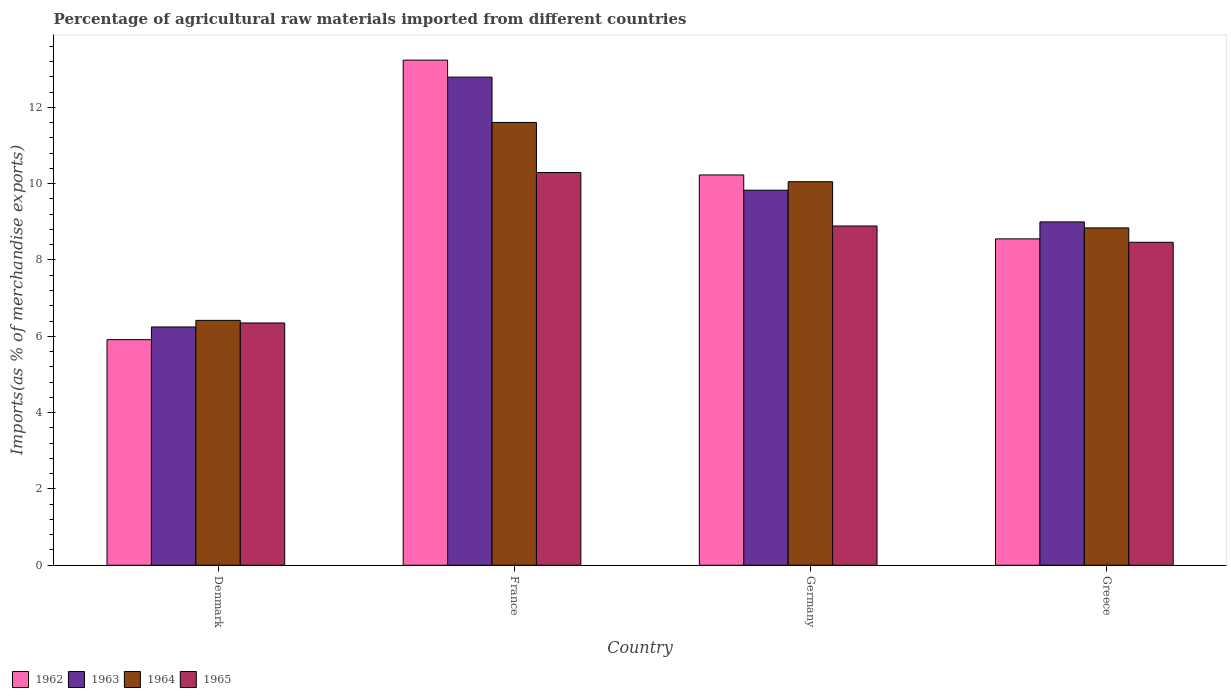How many different coloured bars are there?
Provide a succinct answer. 4. Are the number of bars on each tick of the X-axis equal?
Give a very brief answer. Yes. How many bars are there on the 3rd tick from the left?
Offer a very short reply. 4. How many bars are there on the 3rd tick from the right?
Make the answer very short. 4. What is the label of the 3rd group of bars from the left?
Your answer should be very brief. Germany. In how many cases, is the number of bars for a given country not equal to the number of legend labels?
Keep it short and to the point. 0. What is the percentage of imports to different countries in 1965 in France?
Offer a terse response. 10.29. Across all countries, what is the maximum percentage of imports to different countries in 1965?
Provide a short and direct response. 10.29. Across all countries, what is the minimum percentage of imports to different countries in 1965?
Give a very brief answer. 6.35. In which country was the percentage of imports to different countries in 1965 maximum?
Make the answer very short. France. What is the total percentage of imports to different countries in 1962 in the graph?
Offer a very short reply. 37.93. What is the difference between the percentage of imports to different countries in 1963 in France and that in Greece?
Keep it short and to the point. 3.79. What is the difference between the percentage of imports to different countries in 1964 in Denmark and the percentage of imports to different countries in 1963 in Germany?
Your response must be concise. -3.41. What is the average percentage of imports to different countries in 1964 per country?
Give a very brief answer. 9.23. What is the difference between the percentage of imports to different countries of/in 1963 and percentage of imports to different countries of/in 1964 in France?
Ensure brevity in your answer.  1.19. In how many countries, is the percentage of imports to different countries in 1965 greater than 5.2 %?
Make the answer very short. 4. What is the ratio of the percentage of imports to different countries in 1965 in Denmark to that in France?
Your answer should be very brief. 0.62. What is the difference between the highest and the second highest percentage of imports to different countries in 1962?
Offer a very short reply. -1.67. What is the difference between the highest and the lowest percentage of imports to different countries in 1964?
Ensure brevity in your answer.  5.19. In how many countries, is the percentage of imports to different countries in 1963 greater than the average percentage of imports to different countries in 1963 taken over all countries?
Ensure brevity in your answer.  2. Is the sum of the percentage of imports to different countries in 1965 in Germany and Greece greater than the maximum percentage of imports to different countries in 1962 across all countries?
Provide a succinct answer. Yes. What does the 2nd bar from the right in Germany represents?
Keep it short and to the point. 1964. What is the difference between two consecutive major ticks on the Y-axis?
Give a very brief answer. 2. Does the graph contain any zero values?
Your response must be concise. No. Where does the legend appear in the graph?
Keep it short and to the point. Bottom left. How many legend labels are there?
Your answer should be very brief. 4. What is the title of the graph?
Offer a very short reply. Percentage of agricultural raw materials imported from different countries. What is the label or title of the Y-axis?
Give a very brief answer. Imports(as % of merchandise exports). What is the Imports(as % of merchandise exports) of 1962 in Denmark?
Give a very brief answer. 5.91. What is the Imports(as % of merchandise exports) of 1963 in Denmark?
Offer a terse response. 6.24. What is the Imports(as % of merchandise exports) of 1964 in Denmark?
Keep it short and to the point. 6.42. What is the Imports(as % of merchandise exports) in 1965 in Denmark?
Provide a short and direct response. 6.35. What is the Imports(as % of merchandise exports) in 1962 in France?
Your response must be concise. 13.24. What is the Imports(as % of merchandise exports) of 1963 in France?
Provide a succinct answer. 12.79. What is the Imports(as % of merchandise exports) of 1964 in France?
Give a very brief answer. 11.6. What is the Imports(as % of merchandise exports) in 1965 in France?
Your answer should be very brief. 10.29. What is the Imports(as % of merchandise exports) in 1962 in Germany?
Your answer should be very brief. 10.23. What is the Imports(as % of merchandise exports) of 1963 in Germany?
Provide a succinct answer. 9.83. What is the Imports(as % of merchandise exports) in 1964 in Germany?
Offer a terse response. 10.05. What is the Imports(as % of merchandise exports) in 1965 in Germany?
Offer a terse response. 8.89. What is the Imports(as % of merchandise exports) in 1962 in Greece?
Provide a succinct answer. 8.55. What is the Imports(as % of merchandise exports) in 1963 in Greece?
Provide a succinct answer. 9. What is the Imports(as % of merchandise exports) in 1964 in Greece?
Ensure brevity in your answer.  8.84. What is the Imports(as % of merchandise exports) of 1965 in Greece?
Offer a terse response. 8.46. Across all countries, what is the maximum Imports(as % of merchandise exports) of 1962?
Your answer should be very brief. 13.24. Across all countries, what is the maximum Imports(as % of merchandise exports) of 1963?
Offer a terse response. 12.79. Across all countries, what is the maximum Imports(as % of merchandise exports) in 1964?
Ensure brevity in your answer.  11.6. Across all countries, what is the maximum Imports(as % of merchandise exports) in 1965?
Offer a very short reply. 10.29. Across all countries, what is the minimum Imports(as % of merchandise exports) in 1962?
Offer a terse response. 5.91. Across all countries, what is the minimum Imports(as % of merchandise exports) in 1963?
Provide a succinct answer. 6.24. Across all countries, what is the minimum Imports(as % of merchandise exports) in 1964?
Your answer should be compact. 6.42. Across all countries, what is the minimum Imports(as % of merchandise exports) in 1965?
Make the answer very short. 6.35. What is the total Imports(as % of merchandise exports) in 1962 in the graph?
Your answer should be compact. 37.93. What is the total Imports(as % of merchandise exports) in 1963 in the graph?
Your answer should be very brief. 37.86. What is the total Imports(as % of merchandise exports) in 1964 in the graph?
Provide a succinct answer. 36.91. What is the total Imports(as % of merchandise exports) of 1965 in the graph?
Provide a short and direct response. 33.99. What is the difference between the Imports(as % of merchandise exports) in 1962 in Denmark and that in France?
Make the answer very short. -7.32. What is the difference between the Imports(as % of merchandise exports) of 1963 in Denmark and that in France?
Ensure brevity in your answer.  -6.55. What is the difference between the Imports(as % of merchandise exports) of 1964 in Denmark and that in France?
Give a very brief answer. -5.19. What is the difference between the Imports(as % of merchandise exports) in 1965 in Denmark and that in France?
Your answer should be compact. -3.94. What is the difference between the Imports(as % of merchandise exports) of 1962 in Denmark and that in Germany?
Give a very brief answer. -4.32. What is the difference between the Imports(as % of merchandise exports) in 1963 in Denmark and that in Germany?
Keep it short and to the point. -3.58. What is the difference between the Imports(as % of merchandise exports) of 1964 in Denmark and that in Germany?
Offer a very short reply. -3.63. What is the difference between the Imports(as % of merchandise exports) in 1965 in Denmark and that in Germany?
Offer a terse response. -2.54. What is the difference between the Imports(as % of merchandise exports) in 1962 in Denmark and that in Greece?
Offer a very short reply. -2.64. What is the difference between the Imports(as % of merchandise exports) of 1963 in Denmark and that in Greece?
Keep it short and to the point. -2.75. What is the difference between the Imports(as % of merchandise exports) of 1964 in Denmark and that in Greece?
Keep it short and to the point. -2.42. What is the difference between the Imports(as % of merchandise exports) of 1965 in Denmark and that in Greece?
Make the answer very short. -2.11. What is the difference between the Imports(as % of merchandise exports) of 1962 in France and that in Germany?
Make the answer very short. 3.01. What is the difference between the Imports(as % of merchandise exports) of 1963 in France and that in Germany?
Ensure brevity in your answer.  2.96. What is the difference between the Imports(as % of merchandise exports) in 1964 in France and that in Germany?
Your response must be concise. 1.55. What is the difference between the Imports(as % of merchandise exports) of 1965 in France and that in Germany?
Offer a very short reply. 1.4. What is the difference between the Imports(as % of merchandise exports) of 1962 in France and that in Greece?
Offer a very short reply. 4.68. What is the difference between the Imports(as % of merchandise exports) of 1963 in France and that in Greece?
Ensure brevity in your answer.  3.79. What is the difference between the Imports(as % of merchandise exports) of 1964 in France and that in Greece?
Your answer should be compact. 2.76. What is the difference between the Imports(as % of merchandise exports) in 1965 in France and that in Greece?
Offer a terse response. 1.83. What is the difference between the Imports(as % of merchandise exports) of 1962 in Germany and that in Greece?
Offer a very short reply. 1.67. What is the difference between the Imports(as % of merchandise exports) in 1963 in Germany and that in Greece?
Offer a very short reply. 0.83. What is the difference between the Imports(as % of merchandise exports) in 1964 in Germany and that in Greece?
Provide a short and direct response. 1.21. What is the difference between the Imports(as % of merchandise exports) in 1965 in Germany and that in Greece?
Provide a succinct answer. 0.43. What is the difference between the Imports(as % of merchandise exports) of 1962 in Denmark and the Imports(as % of merchandise exports) of 1963 in France?
Offer a terse response. -6.88. What is the difference between the Imports(as % of merchandise exports) of 1962 in Denmark and the Imports(as % of merchandise exports) of 1964 in France?
Your answer should be compact. -5.69. What is the difference between the Imports(as % of merchandise exports) in 1962 in Denmark and the Imports(as % of merchandise exports) in 1965 in France?
Your answer should be very brief. -4.38. What is the difference between the Imports(as % of merchandise exports) in 1963 in Denmark and the Imports(as % of merchandise exports) in 1964 in France?
Keep it short and to the point. -5.36. What is the difference between the Imports(as % of merchandise exports) in 1963 in Denmark and the Imports(as % of merchandise exports) in 1965 in France?
Keep it short and to the point. -4.05. What is the difference between the Imports(as % of merchandise exports) in 1964 in Denmark and the Imports(as % of merchandise exports) in 1965 in France?
Give a very brief answer. -3.87. What is the difference between the Imports(as % of merchandise exports) in 1962 in Denmark and the Imports(as % of merchandise exports) in 1963 in Germany?
Keep it short and to the point. -3.92. What is the difference between the Imports(as % of merchandise exports) of 1962 in Denmark and the Imports(as % of merchandise exports) of 1964 in Germany?
Offer a terse response. -4.14. What is the difference between the Imports(as % of merchandise exports) of 1962 in Denmark and the Imports(as % of merchandise exports) of 1965 in Germany?
Keep it short and to the point. -2.98. What is the difference between the Imports(as % of merchandise exports) of 1963 in Denmark and the Imports(as % of merchandise exports) of 1964 in Germany?
Make the answer very short. -3.81. What is the difference between the Imports(as % of merchandise exports) in 1963 in Denmark and the Imports(as % of merchandise exports) in 1965 in Germany?
Give a very brief answer. -2.65. What is the difference between the Imports(as % of merchandise exports) in 1964 in Denmark and the Imports(as % of merchandise exports) in 1965 in Germany?
Offer a very short reply. -2.47. What is the difference between the Imports(as % of merchandise exports) in 1962 in Denmark and the Imports(as % of merchandise exports) in 1963 in Greece?
Provide a short and direct response. -3.08. What is the difference between the Imports(as % of merchandise exports) of 1962 in Denmark and the Imports(as % of merchandise exports) of 1964 in Greece?
Your answer should be compact. -2.93. What is the difference between the Imports(as % of merchandise exports) in 1962 in Denmark and the Imports(as % of merchandise exports) in 1965 in Greece?
Make the answer very short. -2.55. What is the difference between the Imports(as % of merchandise exports) of 1963 in Denmark and the Imports(as % of merchandise exports) of 1964 in Greece?
Offer a very short reply. -2.6. What is the difference between the Imports(as % of merchandise exports) in 1963 in Denmark and the Imports(as % of merchandise exports) in 1965 in Greece?
Provide a succinct answer. -2.22. What is the difference between the Imports(as % of merchandise exports) in 1964 in Denmark and the Imports(as % of merchandise exports) in 1965 in Greece?
Ensure brevity in your answer.  -2.05. What is the difference between the Imports(as % of merchandise exports) of 1962 in France and the Imports(as % of merchandise exports) of 1963 in Germany?
Give a very brief answer. 3.41. What is the difference between the Imports(as % of merchandise exports) of 1962 in France and the Imports(as % of merchandise exports) of 1964 in Germany?
Your answer should be compact. 3.19. What is the difference between the Imports(as % of merchandise exports) in 1962 in France and the Imports(as % of merchandise exports) in 1965 in Germany?
Provide a short and direct response. 4.35. What is the difference between the Imports(as % of merchandise exports) of 1963 in France and the Imports(as % of merchandise exports) of 1964 in Germany?
Provide a short and direct response. 2.74. What is the difference between the Imports(as % of merchandise exports) of 1963 in France and the Imports(as % of merchandise exports) of 1965 in Germany?
Ensure brevity in your answer.  3.9. What is the difference between the Imports(as % of merchandise exports) of 1964 in France and the Imports(as % of merchandise exports) of 1965 in Germany?
Ensure brevity in your answer.  2.71. What is the difference between the Imports(as % of merchandise exports) in 1962 in France and the Imports(as % of merchandise exports) in 1963 in Greece?
Offer a very short reply. 4.24. What is the difference between the Imports(as % of merchandise exports) of 1962 in France and the Imports(as % of merchandise exports) of 1964 in Greece?
Make the answer very short. 4.4. What is the difference between the Imports(as % of merchandise exports) in 1962 in France and the Imports(as % of merchandise exports) in 1965 in Greece?
Your response must be concise. 4.77. What is the difference between the Imports(as % of merchandise exports) in 1963 in France and the Imports(as % of merchandise exports) in 1964 in Greece?
Your response must be concise. 3.95. What is the difference between the Imports(as % of merchandise exports) of 1963 in France and the Imports(as % of merchandise exports) of 1965 in Greece?
Your answer should be very brief. 4.33. What is the difference between the Imports(as % of merchandise exports) of 1964 in France and the Imports(as % of merchandise exports) of 1965 in Greece?
Offer a very short reply. 3.14. What is the difference between the Imports(as % of merchandise exports) of 1962 in Germany and the Imports(as % of merchandise exports) of 1963 in Greece?
Provide a succinct answer. 1.23. What is the difference between the Imports(as % of merchandise exports) in 1962 in Germany and the Imports(as % of merchandise exports) in 1964 in Greece?
Your response must be concise. 1.39. What is the difference between the Imports(as % of merchandise exports) of 1962 in Germany and the Imports(as % of merchandise exports) of 1965 in Greece?
Provide a succinct answer. 1.76. What is the difference between the Imports(as % of merchandise exports) of 1963 in Germany and the Imports(as % of merchandise exports) of 1964 in Greece?
Provide a succinct answer. 0.99. What is the difference between the Imports(as % of merchandise exports) in 1963 in Germany and the Imports(as % of merchandise exports) in 1965 in Greece?
Provide a succinct answer. 1.36. What is the difference between the Imports(as % of merchandise exports) in 1964 in Germany and the Imports(as % of merchandise exports) in 1965 in Greece?
Ensure brevity in your answer.  1.59. What is the average Imports(as % of merchandise exports) of 1962 per country?
Make the answer very short. 9.48. What is the average Imports(as % of merchandise exports) of 1963 per country?
Your response must be concise. 9.46. What is the average Imports(as % of merchandise exports) in 1964 per country?
Give a very brief answer. 9.23. What is the average Imports(as % of merchandise exports) in 1965 per country?
Offer a terse response. 8.5. What is the difference between the Imports(as % of merchandise exports) in 1962 and Imports(as % of merchandise exports) in 1963 in Denmark?
Provide a short and direct response. -0.33. What is the difference between the Imports(as % of merchandise exports) of 1962 and Imports(as % of merchandise exports) of 1964 in Denmark?
Ensure brevity in your answer.  -0.51. What is the difference between the Imports(as % of merchandise exports) of 1962 and Imports(as % of merchandise exports) of 1965 in Denmark?
Keep it short and to the point. -0.44. What is the difference between the Imports(as % of merchandise exports) in 1963 and Imports(as % of merchandise exports) in 1964 in Denmark?
Give a very brief answer. -0.17. What is the difference between the Imports(as % of merchandise exports) in 1963 and Imports(as % of merchandise exports) in 1965 in Denmark?
Provide a succinct answer. -0.1. What is the difference between the Imports(as % of merchandise exports) in 1964 and Imports(as % of merchandise exports) in 1965 in Denmark?
Offer a terse response. 0.07. What is the difference between the Imports(as % of merchandise exports) in 1962 and Imports(as % of merchandise exports) in 1963 in France?
Provide a short and direct response. 0.45. What is the difference between the Imports(as % of merchandise exports) of 1962 and Imports(as % of merchandise exports) of 1964 in France?
Offer a terse response. 1.63. What is the difference between the Imports(as % of merchandise exports) in 1962 and Imports(as % of merchandise exports) in 1965 in France?
Ensure brevity in your answer.  2.95. What is the difference between the Imports(as % of merchandise exports) in 1963 and Imports(as % of merchandise exports) in 1964 in France?
Offer a very short reply. 1.19. What is the difference between the Imports(as % of merchandise exports) in 1963 and Imports(as % of merchandise exports) in 1965 in France?
Provide a short and direct response. 2.5. What is the difference between the Imports(as % of merchandise exports) of 1964 and Imports(as % of merchandise exports) of 1965 in France?
Your answer should be very brief. 1.31. What is the difference between the Imports(as % of merchandise exports) of 1962 and Imports(as % of merchandise exports) of 1963 in Germany?
Your response must be concise. 0.4. What is the difference between the Imports(as % of merchandise exports) of 1962 and Imports(as % of merchandise exports) of 1964 in Germany?
Your response must be concise. 0.18. What is the difference between the Imports(as % of merchandise exports) of 1962 and Imports(as % of merchandise exports) of 1965 in Germany?
Your answer should be compact. 1.34. What is the difference between the Imports(as % of merchandise exports) in 1963 and Imports(as % of merchandise exports) in 1964 in Germany?
Offer a terse response. -0.22. What is the difference between the Imports(as % of merchandise exports) in 1963 and Imports(as % of merchandise exports) in 1965 in Germany?
Give a very brief answer. 0.94. What is the difference between the Imports(as % of merchandise exports) of 1964 and Imports(as % of merchandise exports) of 1965 in Germany?
Provide a short and direct response. 1.16. What is the difference between the Imports(as % of merchandise exports) of 1962 and Imports(as % of merchandise exports) of 1963 in Greece?
Your answer should be very brief. -0.44. What is the difference between the Imports(as % of merchandise exports) of 1962 and Imports(as % of merchandise exports) of 1964 in Greece?
Your answer should be very brief. -0.29. What is the difference between the Imports(as % of merchandise exports) in 1962 and Imports(as % of merchandise exports) in 1965 in Greece?
Ensure brevity in your answer.  0.09. What is the difference between the Imports(as % of merchandise exports) in 1963 and Imports(as % of merchandise exports) in 1964 in Greece?
Offer a terse response. 0.16. What is the difference between the Imports(as % of merchandise exports) of 1963 and Imports(as % of merchandise exports) of 1965 in Greece?
Provide a short and direct response. 0.53. What is the difference between the Imports(as % of merchandise exports) of 1964 and Imports(as % of merchandise exports) of 1965 in Greece?
Offer a very short reply. 0.38. What is the ratio of the Imports(as % of merchandise exports) in 1962 in Denmark to that in France?
Ensure brevity in your answer.  0.45. What is the ratio of the Imports(as % of merchandise exports) of 1963 in Denmark to that in France?
Provide a succinct answer. 0.49. What is the ratio of the Imports(as % of merchandise exports) of 1964 in Denmark to that in France?
Keep it short and to the point. 0.55. What is the ratio of the Imports(as % of merchandise exports) in 1965 in Denmark to that in France?
Offer a terse response. 0.62. What is the ratio of the Imports(as % of merchandise exports) in 1962 in Denmark to that in Germany?
Give a very brief answer. 0.58. What is the ratio of the Imports(as % of merchandise exports) in 1963 in Denmark to that in Germany?
Make the answer very short. 0.64. What is the ratio of the Imports(as % of merchandise exports) of 1964 in Denmark to that in Germany?
Give a very brief answer. 0.64. What is the ratio of the Imports(as % of merchandise exports) in 1965 in Denmark to that in Germany?
Your answer should be very brief. 0.71. What is the ratio of the Imports(as % of merchandise exports) of 1962 in Denmark to that in Greece?
Keep it short and to the point. 0.69. What is the ratio of the Imports(as % of merchandise exports) in 1963 in Denmark to that in Greece?
Your answer should be compact. 0.69. What is the ratio of the Imports(as % of merchandise exports) of 1964 in Denmark to that in Greece?
Make the answer very short. 0.73. What is the ratio of the Imports(as % of merchandise exports) in 1965 in Denmark to that in Greece?
Offer a very short reply. 0.75. What is the ratio of the Imports(as % of merchandise exports) in 1962 in France to that in Germany?
Offer a terse response. 1.29. What is the ratio of the Imports(as % of merchandise exports) of 1963 in France to that in Germany?
Offer a terse response. 1.3. What is the ratio of the Imports(as % of merchandise exports) of 1964 in France to that in Germany?
Keep it short and to the point. 1.15. What is the ratio of the Imports(as % of merchandise exports) of 1965 in France to that in Germany?
Make the answer very short. 1.16. What is the ratio of the Imports(as % of merchandise exports) of 1962 in France to that in Greece?
Keep it short and to the point. 1.55. What is the ratio of the Imports(as % of merchandise exports) of 1963 in France to that in Greece?
Offer a very short reply. 1.42. What is the ratio of the Imports(as % of merchandise exports) in 1964 in France to that in Greece?
Provide a succinct answer. 1.31. What is the ratio of the Imports(as % of merchandise exports) of 1965 in France to that in Greece?
Your answer should be very brief. 1.22. What is the ratio of the Imports(as % of merchandise exports) of 1962 in Germany to that in Greece?
Offer a very short reply. 1.2. What is the ratio of the Imports(as % of merchandise exports) of 1963 in Germany to that in Greece?
Keep it short and to the point. 1.09. What is the ratio of the Imports(as % of merchandise exports) in 1964 in Germany to that in Greece?
Provide a short and direct response. 1.14. What is the ratio of the Imports(as % of merchandise exports) in 1965 in Germany to that in Greece?
Keep it short and to the point. 1.05. What is the difference between the highest and the second highest Imports(as % of merchandise exports) in 1962?
Your answer should be compact. 3.01. What is the difference between the highest and the second highest Imports(as % of merchandise exports) of 1963?
Make the answer very short. 2.96. What is the difference between the highest and the second highest Imports(as % of merchandise exports) in 1964?
Offer a terse response. 1.55. What is the difference between the highest and the second highest Imports(as % of merchandise exports) of 1965?
Your answer should be compact. 1.4. What is the difference between the highest and the lowest Imports(as % of merchandise exports) in 1962?
Your answer should be compact. 7.32. What is the difference between the highest and the lowest Imports(as % of merchandise exports) in 1963?
Make the answer very short. 6.55. What is the difference between the highest and the lowest Imports(as % of merchandise exports) of 1964?
Keep it short and to the point. 5.19. What is the difference between the highest and the lowest Imports(as % of merchandise exports) in 1965?
Ensure brevity in your answer.  3.94. 